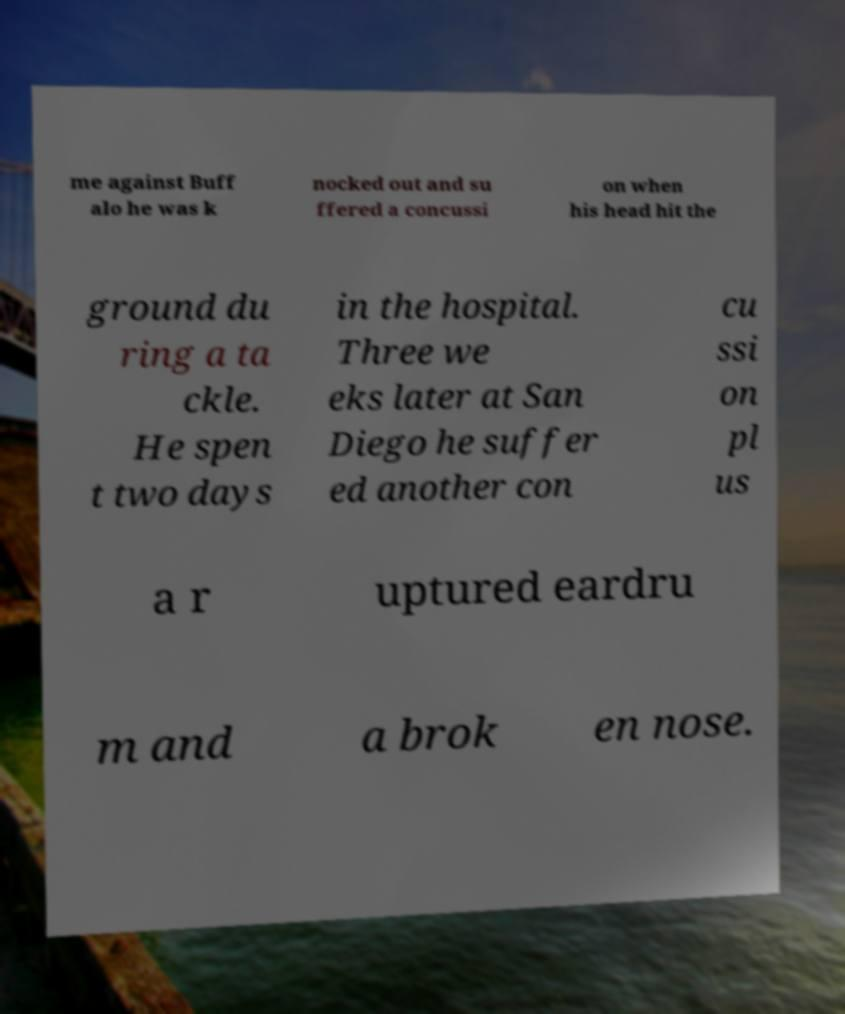There's text embedded in this image that I need extracted. Can you transcribe it verbatim? me against Buff alo he was k nocked out and su ffered a concussi on when his head hit the ground du ring a ta ckle. He spen t two days in the hospital. Three we eks later at San Diego he suffer ed another con cu ssi on pl us a r uptured eardru m and a brok en nose. 